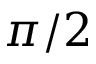Convert formula to latex. <formula><loc_0><loc_0><loc_500><loc_500>\pi / 2</formula> 